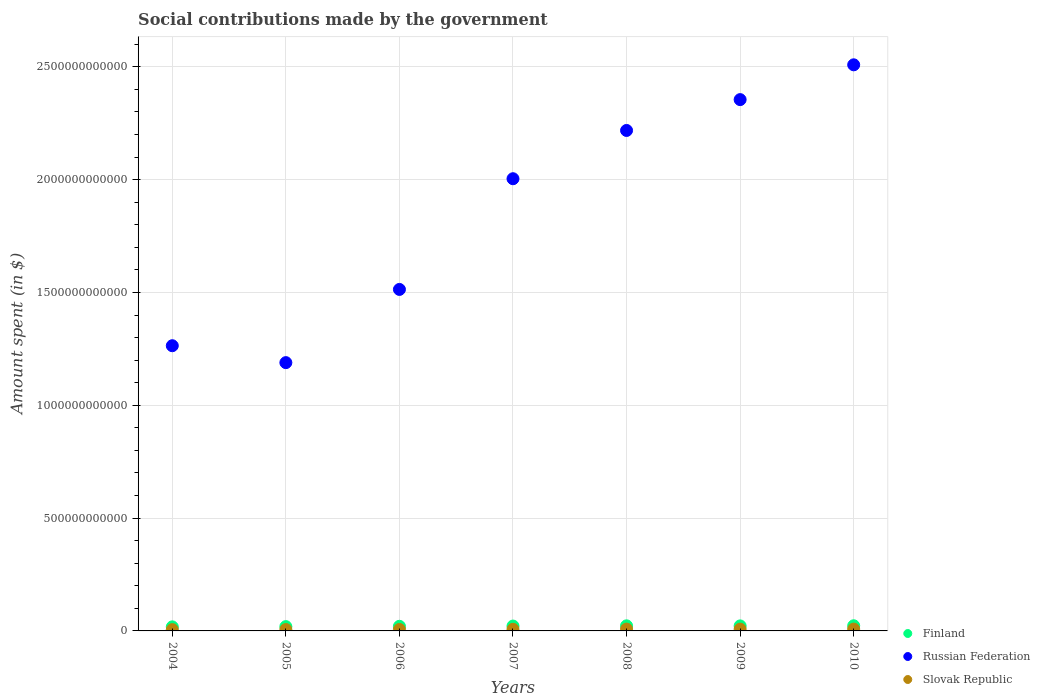What is the amount spent on social contributions in Slovak Republic in 2007?
Give a very brief answer. 7.23e+09. Across all years, what is the maximum amount spent on social contributions in Slovak Republic?
Offer a very short reply. 8.18e+09. Across all years, what is the minimum amount spent on social contributions in Slovak Republic?
Provide a short and direct response. 5.69e+09. What is the total amount spent on social contributions in Russian Federation in the graph?
Provide a short and direct response. 1.31e+13. What is the difference between the amount spent on social contributions in Finland in 2004 and that in 2009?
Keep it short and to the point. -4.28e+09. What is the difference between the amount spent on social contributions in Russian Federation in 2007 and the amount spent on social contributions in Slovak Republic in 2008?
Keep it short and to the point. 2.00e+12. What is the average amount spent on social contributions in Finland per year?
Offer a very short reply. 2.10e+1. In the year 2010, what is the difference between the amount spent on social contributions in Russian Federation and amount spent on social contributions in Finland?
Ensure brevity in your answer.  2.49e+12. What is the ratio of the amount spent on social contributions in Russian Federation in 2005 to that in 2010?
Your response must be concise. 0.47. What is the difference between the highest and the second highest amount spent on social contributions in Finland?
Your answer should be compact. 3.15e+08. What is the difference between the highest and the lowest amount spent on social contributions in Finland?
Give a very brief answer. 4.89e+09. Is it the case that in every year, the sum of the amount spent on social contributions in Russian Federation and amount spent on social contributions in Slovak Republic  is greater than the amount spent on social contributions in Finland?
Provide a short and direct response. Yes. Does the amount spent on social contributions in Finland monotonically increase over the years?
Make the answer very short. No. Is the amount spent on social contributions in Russian Federation strictly less than the amount spent on social contributions in Finland over the years?
Offer a terse response. No. How many dotlines are there?
Keep it short and to the point. 3. What is the difference between two consecutive major ticks on the Y-axis?
Make the answer very short. 5.00e+11. Where does the legend appear in the graph?
Offer a very short reply. Bottom right. How are the legend labels stacked?
Offer a very short reply. Vertical. What is the title of the graph?
Give a very brief answer. Social contributions made by the government. What is the label or title of the X-axis?
Ensure brevity in your answer.  Years. What is the label or title of the Y-axis?
Your answer should be compact. Amount spent (in $). What is the Amount spent (in $) of Finland in 2004?
Give a very brief answer. 1.80e+1. What is the Amount spent (in $) in Russian Federation in 2004?
Your answer should be very brief. 1.26e+12. What is the Amount spent (in $) in Slovak Republic in 2004?
Your response must be concise. 5.69e+09. What is the Amount spent (in $) of Finland in 2005?
Provide a succinct answer. 1.91e+1. What is the Amount spent (in $) of Russian Federation in 2005?
Your answer should be compact. 1.19e+12. What is the Amount spent (in $) of Slovak Republic in 2005?
Make the answer very short. 6.11e+09. What is the Amount spent (in $) in Finland in 2006?
Ensure brevity in your answer.  2.05e+1. What is the Amount spent (in $) of Russian Federation in 2006?
Offer a terse response. 1.51e+12. What is the Amount spent (in $) in Slovak Republic in 2006?
Provide a short and direct response. 6.59e+09. What is the Amount spent (in $) in Finland in 2007?
Ensure brevity in your answer.  2.16e+1. What is the Amount spent (in $) of Russian Federation in 2007?
Offer a very short reply. 2.00e+12. What is the Amount spent (in $) in Slovak Republic in 2007?
Keep it short and to the point. 7.23e+09. What is the Amount spent (in $) of Finland in 2008?
Give a very brief answer. 2.25e+1. What is the Amount spent (in $) in Russian Federation in 2008?
Provide a short and direct response. 2.22e+12. What is the Amount spent (in $) in Slovak Republic in 2008?
Provide a succinct answer. 8.07e+09. What is the Amount spent (in $) of Finland in 2009?
Your answer should be very brief. 2.22e+1. What is the Amount spent (in $) of Russian Federation in 2009?
Your answer should be very brief. 2.35e+12. What is the Amount spent (in $) in Slovak Republic in 2009?
Offer a terse response. 7.99e+09. What is the Amount spent (in $) of Finland in 2010?
Offer a very short reply. 2.29e+1. What is the Amount spent (in $) of Russian Federation in 2010?
Your response must be concise. 2.51e+12. What is the Amount spent (in $) of Slovak Republic in 2010?
Your response must be concise. 8.18e+09. Across all years, what is the maximum Amount spent (in $) in Finland?
Offer a terse response. 2.29e+1. Across all years, what is the maximum Amount spent (in $) of Russian Federation?
Your answer should be compact. 2.51e+12. Across all years, what is the maximum Amount spent (in $) of Slovak Republic?
Provide a short and direct response. 8.18e+09. Across all years, what is the minimum Amount spent (in $) in Finland?
Offer a terse response. 1.80e+1. Across all years, what is the minimum Amount spent (in $) in Russian Federation?
Give a very brief answer. 1.19e+12. Across all years, what is the minimum Amount spent (in $) in Slovak Republic?
Make the answer very short. 5.69e+09. What is the total Amount spent (in $) of Finland in the graph?
Your answer should be very brief. 1.47e+11. What is the total Amount spent (in $) of Russian Federation in the graph?
Your answer should be compact. 1.31e+13. What is the total Amount spent (in $) in Slovak Republic in the graph?
Offer a terse response. 4.99e+1. What is the difference between the Amount spent (in $) in Finland in 2004 and that in 2005?
Offer a terse response. -1.12e+09. What is the difference between the Amount spent (in $) in Russian Federation in 2004 and that in 2005?
Offer a very short reply. 7.49e+1. What is the difference between the Amount spent (in $) in Slovak Republic in 2004 and that in 2005?
Provide a short and direct response. -4.22e+08. What is the difference between the Amount spent (in $) in Finland in 2004 and that in 2006?
Keep it short and to the point. -2.52e+09. What is the difference between the Amount spent (in $) of Russian Federation in 2004 and that in 2006?
Offer a very short reply. -2.49e+11. What is the difference between the Amount spent (in $) of Slovak Republic in 2004 and that in 2006?
Offer a terse response. -8.98e+08. What is the difference between the Amount spent (in $) of Finland in 2004 and that in 2007?
Offer a very short reply. -3.63e+09. What is the difference between the Amount spent (in $) of Russian Federation in 2004 and that in 2007?
Provide a succinct answer. -7.40e+11. What is the difference between the Amount spent (in $) in Slovak Republic in 2004 and that in 2007?
Your response must be concise. -1.54e+09. What is the difference between the Amount spent (in $) of Finland in 2004 and that in 2008?
Give a very brief answer. -4.57e+09. What is the difference between the Amount spent (in $) of Russian Federation in 2004 and that in 2008?
Your answer should be very brief. -9.54e+11. What is the difference between the Amount spent (in $) of Slovak Republic in 2004 and that in 2008?
Provide a short and direct response. -2.38e+09. What is the difference between the Amount spent (in $) of Finland in 2004 and that in 2009?
Give a very brief answer. -4.28e+09. What is the difference between the Amount spent (in $) of Russian Federation in 2004 and that in 2009?
Provide a succinct answer. -1.09e+12. What is the difference between the Amount spent (in $) in Slovak Republic in 2004 and that in 2009?
Provide a short and direct response. -2.30e+09. What is the difference between the Amount spent (in $) in Finland in 2004 and that in 2010?
Your response must be concise. -4.89e+09. What is the difference between the Amount spent (in $) of Russian Federation in 2004 and that in 2010?
Keep it short and to the point. -1.24e+12. What is the difference between the Amount spent (in $) of Slovak Republic in 2004 and that in 2010?
Ensure brevity in your answer.  -2.49e+09. What is the difference between the Amount spent (in $) of Finland in 2005 and that in 2006?
Keep it short and to the point. -1.39e+09. What is the difference between the Amount spent (in $) of Russian Federation in 2005 and that in 2006?
Offer a very short reply. -3.24e+11. What is the difference between the Amount spent (in $) of Slovak Republic in 2005 and that in 2006?
Ensure brevity in your answer.  -4.75e+08. What is the difference between the Amount spent (in $) in Finland in 2005 and that in 2007?
Your answer should be very brief. -2.50e+09. What is the difference between the Amount spent (in $) of Russian Federation in 2005 and that in 2007?
Give a very brief answer. -8.15e+11. What is the difference between the Amount spent (in $) in Slovak Republic in 2005 and that in 2007?
Make the answer very short. -1.12e+09. What is the difference between the Amount spent (in $) of Finland in 2005 and that in 2008?
Offer a very short reply. -3.45e+09. What is the difference between the Amount spent (in $) of Russian Federation in 2005 and that in 2008?
Your answer should be compact. -1.03e+12. What is the difference between the Amount spent (in $) in Slovak Republic in 2005 and that in 2008?
Give a very brief answer. -1.96e+09. What is the difference between the Amount spent (in $) in Finland in 2005 and that in 2009?
Offer a terse response. -3.15e+09. What is the difference between the Amount spent (in $) of Russian Federation in 2005 and that in 2009?
Your response must be concise. -1.17e+12. What is the difference between the Amount spent (in $) in Slovak Republic in 2005 and that in 2009?
Provide a succinct answer. -1.88e+09. What is the difference between the Amount spent (in $) of Finland in 2005 and that in 2010?
Your answer should be compact. -3.76e+09. What is the difference between the Amount spent (in $) of Russian Federation in 2005 and that in 2010?
Keep it short and to the point. -1.32e+12. What is the difference between the Amount spent (in $) of Slovak Republic in 2005 and that in 2010?
Provide a short and direct response. -2.07e+09. What is the difference between the Amount spent (in $) of Finland in 2006 and that in 2007?
Provide a short and direct response. -1.11e+09. What is the difference between the Amount spent (in $) of Russian Federation in 2006 and that in 2007?
Give a very brief answer. -4.91e+11. What is the difference between the Amount spent (in $) of Slovak Republic in 2006 and that in 2007?
Give a very brief answer. -6.41e+08. What is the difference between the Amount spent (in $) in Finland in 2006 and that in 2008?
Your response must be concise. -2.05e+09. What is the difference between the Amount spent (in $) in Russian Federation in 2006 and that in 2008?
Offer a terse response. -7.04e+11. What is the difference between the Amount spent (in $) in Slovak Republic in 2006 and that in 2008?
Offer a very short reply. -1.48e+09. What is the difference between the Amount spent (in $) in Finland in 2006 and that in 2009?
Give a very brief answer. -1.76e+09. What is the difference between the Amount spent (in $) of Russian Federation in 2006 and that in 2009?
Provide a succinct answer. -8.41e+11. What is the difference between the Amount spent (in $) of Slovak Republic in 2006 and that in 2009?
Offer a terse response. -1.41e+09. What is the difference between the Amount spent (in $) of Finland in 2006 and that in 2010?
Offer a terse response. -2.37e+09. What is the difference between the Amount spent (in $) in Russian Federation in 2006 and that in 2010?
Your response must be concise. -9.95e+11. What is the difference between the Amount spent (in $) of Slovak Republic in 2006 and that in 2010?
Your response must be concise. -1.60e+09. What is the difference between the Amount spent (in $) of Finland in 2007 and that in 2008?
Offer a very short reply. -9.45e+08. What is the difference between the Amount spent (in $) in Russian Federation in 2007 and that in 2008?
Offer a terse response. -2.14e+11. What is the difference between the Amount spent (in $) in Slovak Republic in 2007 and that in 2008?
Give a very brief answer. -8.43e+08. What is the difference between the Amount spent (in $) in Finland in 2007 and that in 2009?
Your answer should be compact. -6.51e+08. What is the difference between the Amount spent (in $) in Russian Federation in 2007 and that in 2009?
Offer a terse response. -3.51e+11. What is the difference between the Amount spent (in $) in Slovak Republic in 2007 and that in 2009?
Provide a short and direct response. -7.65e+08. What is the difference between the Amount spent (in $) in Finland in 2007 and that in 2010?
Offer a terse response. -1.26e+09. What is the difference between the Amount spent (in $) in Russian Federation in 2007 and that in 2010?
Provide a succinct answer. -5.05e+11. What is the difference between the Amount spent (in $) in Slovak Republic in 2007 and that in 2010?
Offer a very short reply. -9.55e+08. What is the difference between the Amount spent (in $) in Finland in 2008 and that in 2009?
Keep it short and to the point. 2.94e+08. What is the difference between the Amount spent (in $) of Russian Federation in 2008 and that in 2009?
Provide a short and direct response. -1.37e+11. What is the difference between the Amount spent (in $) of Slovak Republic in 2008 and that in 2009?
Provide a short and direct response. 7.78e+07. What is the difference between the Amount spent (in $) of Finland in 2008 and that in 2010?
Your response must be concise. -3.15e+08. What is the difference between the Amount spent (in $) in Russian Federation in 2008 and that in 2010?
Give a very brief answer. -2.91e+11. What is the difference between the Amount spent (in $) of Slovak Republic in 2008 and that in 2010?
Your response must be concise. -1.13e+08. What is the difference between the Amount spent (in $) in Finland in 2009 and that in 2010?
Offer a very short reply. -6.09e+08. What is the difference between the Amount spent (in $) of Russian Federation in 2009 and that in 2010?
Offer a very short reply. -1.54e+11. What is the difference between the Amount spent (in $) in Slovak Republic in 2009 and that in 2010?
Keep it short and to the point. -1.91e+08. What is the difference between the Amount spent (in $) in Finland in 2004 and the Amount spent (in $) in Russian Federation in 2005?
Offer a terse response. -1.17e+12. What is the difference between the Amount spent (in $) of Finland in 2004 and the Amount spent (in $) of Slovak Republic in 2005?
Ensure brevity in your answer.  1.19e+1. What is the difference between the Amount spent (in $) in Russian Federation in 2004 and the Amount spent (in $) in Slovak Republic in 2005?
Make the answer very short. 1.26e+12. What is the difference between the Amount spent (in $) in Finland in 2004 and the Amount spent (in $) in Russian Federation in 2006?
Your answer should be very brief. -1.50e+12. What is the difference between the Amount spent (in $) in Finland in 2004 and the Amount spent (in $) in Slovak Republic in 2006?
Ensure brevity in your answer.  1.14e+1. What is the difference between the Amount spent (in $) in Russian Federation in 2004 and the Amount spent (in $) in Slovak Republic in 2006?
Your response must be concise. 1.26e+12. What is the difference between the Amount spent (in $) in Finland in 2004 and the Amount spent (in $) in Russian Federation in 2007?
Offer a terse response. -1.99e+12. What is the difference between the Amount spent (in $) of Finland in 2004 and the Amount spent (in $) of Slovak Republic in 2007?
Offer a very short reply. 1.07e+1. What is the difference between the Amount spent (in $) of Russian Federation in 2004 and the Amount spent (in $) of Slovak Republic in 2007?
Your response must be concise. 1.26e+12. What is the difference between the Amount spent (in $) in Finland in 2004 and the Amount spent (in $) in Russian Federation in 2008?
Provide a succinct answer. -2.20e+12. What is the difference between the Amount spent (in $) of Finland in 2004 and the Amount spent (in $) of Slovak Republic in 2008?
Your answer should be very brief. 9.90e+09. What is the difference between the Amount spent (in $) of Russian Federation in 2004 and the Amount spent (in $) of Slovak Republic in 2008?
Offer a terse response. 1.26e+12. What is the difference between the Amount spent (in $) of Finland in 2004 and the Amount spent (in $) of Russian Federation in 2009?
Make the answer very short. -2.34e+12. What is the difference between the Amount spent (in $) in Finland in 2004 and the Amount spent (in $) in Slovak Republic in 2009?
Offer a terse response. 9.98e+09. What is the difference between the Amount spent (in $) of Russian Federation in 2004 and the Amount spent (in $) of Slovak Republic in 2009?
Give a very brief answer. 1.26e+12. What is the difference between the Amount spent (in $) in Finland in 2004 and the Amount spent (in $) in Russian Federation in 2010?
Your answer should be compact. -2.49e+12. What is the difference between the Amount spent (in $) of Finland in 2004 and the Amount spent (in $) of Slovak Republic in 2010?
Make the answer very short. 9.79e+09. What is the difference between the Amount spent (in $) in Russian Federation in 2004 and the Amount spent (in $) in Slovak Republic in 2010?
Provide a succinct answer. 1.26e+12. What is the difference between the Amount spent (in $) in Finland in 2005 and the Amount spent (in $) in Russian Federation in 2006?
Your answer should be compact. -1.49e+12. What is the difference between the Amount spent (in $) in Finland in 2005 and the Amount spent (in $) in Slovak Republic in 2006?
Your response must be concise. 1.25e+1. What is the difference between the Amount spent (in $) of Russian Federation in 2005 and the Amount spent (in $) of Slovak Republic in 2006?
Offer a terse response. 1.18e+12. What is the difference between the Amount spent (in $) in Finland in 2005 and the Amount spent (in $) in Russian Federation in 2007?
Offer a terse response. -1.98e+12. What is the difference between the Amount spent (in $) of Finland in 2005 and the Amount spent (in $) of Slovak Republic in 2007?
Give a very brief answer. 1.19e+1. What is the difference between the Amount spent (in $) of Russian Federation in 2005 and the Amount spent (in $) of Slovak Republic in 2007?
Provide a succinct answer. 1.18e+12. What is the difference between the Amount spent (in $) in Finland in 2005 and the Amount spent (in $) in Russian Federation in 2008?
Offer a very short reply. -2.20e+12. What is the difference between the Amount spent (in $) in Finland in 2005 and the Amount spent (in $) in Slovak Republic in 2008?
Make the answer very short. 1.10e+1. What is the difference between the Amount spent (in $) of Russian Federation in 2005 and the Amount spent (in $) of Slovak Republic in 2008?
Offer a terse response. 1.18e+12. What is the difference between the Amount spent (in $) in Finland in 2005 and the Amount spent (in $) in Russian Federation in 2009?
Your answer should be compact. -2.34e+12. What is the difference between the Amount spent (in $) in Finland in 2005 and the Amount spent (in $) in Slovak Republic in 2009?
Your response must be concise. 1.11e+1. What is the difference between the Amount spent (in $) of Russian Federation in 2005 and the Amount spent (in $) of Slovak Republic in 2009?
Offer a terse response. 1.18e+12. What is the difference between the Amount spent (in $) of Finland in 2005 and the Amount spent (in $) of Russian Federation in 2010?
Your response must be concise. -2.49e+12. What is the difference between the Amount spent (in $) of Finland in 2005 and the Amount spent (in $) of Slovak Republic in 2010?
Your answer should be very brief. 1.09e+1. What is the difference between the Amount spent (in $) of Russian Federation in 2005 and the Amount spent (in $) of Slovak Republic in 2010?
Your answer should be compact. 1.18e+12. What is the difference between the Amount spent (in $) in Finland in 2006 and the Amount spent (in $) in Russian Federation in 2007?
Your response must be concise. -1.98e+12. What is the difference between the Amount spent (in $) of Finland in 2006 and the Amount spent (in $) of Slovak Republic in 2007?
Your response must be concise. 1.33e+1. What is the difference between the Amount spent (in $) in Russian Federation in 2006 and the Amount spent (in $) in Slovak Republic in 2007?
Provide a succinct answer. 1.51e+12. What is the difference between the Amount spent (in $) of Finland in 2006 and the Amount spent (in $) of Russian Federation in 2008?
Make the answer very short. -2.20e+12. What is the difference between the Amount spent (in $) of Finland in 2006 and the Amount spent (in $) of Slovak Republic in 2008?
Give a very brief answer. 1.24e+1. What is the difference between the Amount spent (in $) of Russian Federation in 2006 and the Amount spent (in $) of Slovak Republic in 2008?
Your answer should be compact. 1.51e+12. What is the difference between the Amount spent (in $) in Finland in 2006 and the Amount spent (in $) in Russian Federation in 2009?
Provide a short and direct response. -2.33e+12. What is the difference between the Amount spent (in $) of Finland in 2006 and the Amount spent (in $) of Slovak Republic in 2009?
Provide a succinct answer. 1.25e+1. What is the difference between the Amount spent (in $) of Russian Federation in 2006 and the Amount spent (in $) of Slovak Republic in 2009?
Keep it short and to the point. 1.51e+12. What is the difference between the Amount spent (in $) of Finland in 2006 and the Amount spent (in $) of Russian Federation in 2010?
Provide a short and direct response. -2.49e+12. What is the difference between the Amount spent (in $) in Finland in 2006 and the Amount spent (in $) in Slovak Republic in 2010?
Your answer should be very brief. 1.23e+1. What is the difference between the Amount spent (in $) of Russian Federation in 2006 and the Amount spent (in $) of Slovak Republic in 2010?
Your answer should be compact. 1.51e+12. What is the difference between the Amount spent (in $) of Finland in 2007 and the Amount spent (in $) of Russian Federation in 2008?
Offer a very short reply. -2.20e+12. What is the difference between the Amount spent (in $) in Finland in 2007 and the Amount spent (in $) in Slovak Republic in 2008?
Keep it short and to the point. 1.35e+1. What is the difference between the Amount spent (in $) in Russian Federation in 2007 and the Amount spent (in $) in Slovak Republic in 2008?
Offer a very short reply. 2.00e+12. What is the difference between the Amount spent (in $) in Finland in 2007 and the Amount spent (in $) in Russian Federation in 2009?
Give a very brief answer. -2.33e+12. What is the difference between the Amount spent (in $) of Finland in 2007 and the Amount spent (in $) of Slovak Republic in 2009?
Your answer should be compact. 1.36e+1. What is the difference between the Amount spent (in $) of Russian Federation in 2007 and the Amount spent (in $) of Slovak Republic in 2009?
Offer a very short reply. 2.00e+12. What is the difference between the Amount spent (in $) in Finland in 2007 and the Amount spent (in $) in Russian Federation in 2010?
Provide a short and direct response. -2.49e+12. What is the difference between the Amount spent (in $) in Finland in 2007 and the Amount spent (in $) in Slovak Republic in 2010?
Provide a succinct answer. 1.34e+1. What is the difference between the Amount spent (in $) of Russian Federation in 2007 and the Amount spent (in $) of Slovak Republic in 2010?
Make the answer very short. 2.00e+12. What is the difference between the Amount spent (in $) in Finland in 2008 and the Amount spent (in $) in Russian Federation in 2009?
Offer a terse response. -2.33e+12. What is the difference between the Amount spent (in $) in Finland in 2008 and the Amount spent (in $) in Slovak Republic in 2009?
Offer a very short reply. 1.45e+1. What is the difference between the Amount spent (in $) in Russian Federation in 2008 and the Amount spent (in $) in Slovak Republic in 2009?
Your answer should be very brief. 2.21e+12. What is the difference between the Amount spent (in $) of Finland in 2008 and the Amount spent (in $) of Russian Federation in 2010?
Keep it short and to the point. -2.49e+12. What is the difference between the Amount spent (in $) of Finland in 2008 and the Amount spent (in $) of Slovak Republic in 2010?
Offer a terse response. 1.44e+1. What is the difference between the Amount spent (in $) of Russian Federation in 2008 and the Amount spent (in $) of Slovak Republic in 2010?
Offer a very short reply. 2.21e+12. What is the difference between the Amount spent (in $) in Finland in 2009 and the Amount spent (in $) in Russian Federation in 2010?
Give a very brief answer. -2.49e+12. What is the difference between the Amount spent (in $) in Finland in 2009 and the Amount spent (in $) in Slovak Republic in 2010?
Offer a terse response. 1.41e+1. What is the difference between the Amount spent (in $) of Russian Federation in 2009 and the Amount spent (in $) of Slovak Republic in 2010?
Offer a very short reply. 2.35e+12. What is the average Amount spent (in $) in Finland per year?
Provide a succinct answer. 2.10e+1. What is the average Amount spent (in $) in Russian Federation per year?
Keep it short and to the point. 1.86e+12. What is the average Amount spent (in $) of Slovak Republic per year?
Your answer should be compact. 7.12e+09. In the year 2004, what is the difference between the Amount spent (in $) in Finland and Amount spent (in $) in Russian Federation?
Provide a succinct answer. -1.25e+12. In the year 2004, what is the difference between the Amount spent (in $) in Finland and Amount spent (in $) in Slovak Republic?
Your answer should be very brief. 1.23e+1. In the year 2004, what is the difference between the Amount spent (in $) of Russian Federation and Amount spent (in $) of Slovak Republic?
Provide a succinct answer. 1.26e+12. In the year 2005, what is the difference between the Amount spent (in $) of Finland and Amount spent (in $) of Russian Federation?
Make the answer very short. -1.17e+12. In the year 2005, what is the difference between the Amount spent (in $) in Finland and Amount spent (in $) in Slovak Republic?
Make the answer very short. 1.30e+1. In the year 2005, what is the difference between the Amount spent (in $) of Russian Federation and Amount spent (in $) of Slovak Republic?
Offer a terse response. 1.18e+12. In the year 2006, what is the difference between the Amount spent (in $) of Finland and Amount spent (in $) of Russian Federation?
Offer a terse response. -1.49e+12. In the year 2006, what is the difference between the Amount spent (in $) of Finland and Amount spent (in $) of Slovak Republic?
Make the answer very short. 1.39e+1. In the year 2006, what is the difference between the Amount spent (in $) in Russian Federation and Amount spent (in $) in Slovak Republic?
Your answer should be very brief. 1.51e+12. In the year 2007, what is the difference between the Amount spent (in $) of Finland and Amount spent (in $) of Russian Federation?
Your answer should be very brief. -1.98e+12. In the year 2007, what is the difference between the Amount spent (in $) in Finland and Amount spent (in $) in Slovak Republic?
Provide a short and direct response. 1.44e+1. In the year 2007, what is the difference between the Amount spent (in $) in Russian Federation and Amount spent (in $) in Slovak Republic?
Make the answer very short. 2.00e+12. In the year 2008, what is the difference between the Amount spent (in $) of Finland and Amount spent (in $) of Russian Federation?
Provide a short and direct response. -2.20e+12. In the year 2008, what is the difference between the Amount spent (in $) in Finland and Amount spent (in $) in Slovak Republic?
Your response must be concise. 1.45e+1. In the year 2008, what is the difference between the Amount spent (in $) in Russian Federation and Amount spent (in $) in Slovak Republic?
Offer a very short reply. 2.21e+12. In the year 2009, what is the difference between the Amount spent (in $) of Finland and Amount spent (in $) of Russian Federation?
Your answer should be very brief. -2.33e+12. In the year 2009, what is the difference between the Amount spent (in $) of Finland and Amount spent (in $) of Slovak Republic?
Your answer should be compact. 1.43e+1. In the year 2009, what is the difference between the Amount spent (in $) in Russian Federation and Amount spent (in $) in Slovak Republic?
Provide a succinct answer. 2.35e+12. In the year 2010, what is the difference between the Amount spent (in $) of Finland and Amount spent (in $) of Russian Federation?
Your answer should be very brief. -2.49e+12. In the year 2010, what is the difference between the Amount spent (in $) of Finland and Amount spent (in $) of Slovak Republic?
Provide a succinct answer. 1.47e+1. In the year 2010, what is the difference between the Amount spent (in $) in Russian Federation and Amount spent (in $) in Slovak Republic?
Offer a terse response. 2.50e+12. What is the ratio of the Amount spent (in $) of Finland in 2004 to that in 2005?
Ensure brevity in your answer.  0.94. What is the ratio of the Amount spent (in $) in Russian Federation in 2004 to that in 2005?
Provide a succinct answer. 1.06. What is the ratio of the Amount spent (in $) of Slovak Republic in 2004 to that in 2005?
Make the answer very short. 0.93. What is the ratio of the Amount spent (in $) of Finland in 2004 to that in 2006?
Offer a terse response. 0.88. What is the ratio of the Amount spent (in $) in Russian Federation in 2004 to that in 2006?
Your response must be concise. 0.84. What is the ratio of the Amount spent (in $) of Slovak Republic in 2004 to that in 2006?
Provide a succinct answer. 0.86. What is the ratio of the Amount spent (in $) of Finland in 2004 to that in 2007?
Provide a succinct answer. 0.83. What is the ratio of the Amount spent (in $) in Russian Federation in 2004 to that in 2007?
Ensure brevity in your answer.  0.63. What is the ratio of the Amount spent (in $) in Slovak Republic in 2004 to that in 2007?
Your answer should be compact. 0.79. What is the ratio of the Amount spent (in $) of Finland in 2004 to that in 2008?
Keep it short and to the point. 0.8. What is the ratio of the Amount spent (in $) in Russian Federation in 2004 to that in 2008?
Provide a short and direct response. 0.57. What is the ratio of the Amount spent (in $) in Slovak Republic in 2004 to that in 2008?
Offer a very short reply. 0.7. What is the ratio of the Amount spent (in $) of Finland in 2004 to that in 2009?
Offer a terse response. 0.81. What is the ratio of the Amount spent (in $) of Russian Federation in 2004 to that in 2009?
Offer a very short reply. 0.54. What is the ratio of the Amount spent (in $) of Slovak Republic in 2004 to that in 2009?
Your response must be concise. 0.71. What is the ratio of the Amount spent (in $) in Finland in 2004 to that in 2010?
Offer a terse response. 0.79. What is the ratio of the Amount spent (in $) in Russian Federation in 2004 to that in 2010?
Your response must be concise. 0.5. What is the ratio of the Amount spent (in $) in Slovak Republic in 2004 to that in 2010?
Provide a succinct answer. 0.7. What is the ratio of the Amount spent (in $) of Finland in 2005 to that in 2006?
Offer a terse response. 0.93. What is the ratio of the Amount spent (in $) in Russian Federation in 2005 to that in 2006?
Give a very brief answer. 0.79. What is the ratio of the Amount spent (in $) in Slovak Republic in 2005 to that in 2006?
Keep it short and to the point. 0.93. What is the ratio of the Amount spent (in $) in Finland in 2005 to that in 2007?
Your answer should be compact. 0.88. What is the ratio of the Amount spent (in $) in Russian Federation in 2005 to that in 2007?
Your answer should be compact. 0.59. What is the ratio of the Amount spent (in $) of Slovak Republic in 2005 to that in 2007?
Provide a succinct answer. 0.85. What is the ratio of the Amount spent (in $) in Finland in 2005 to that in 2008?
Provide a short and direct response. 0.85. What is the ratio of the Amount spent (in $) of Russian Federation in 2005 to that in 2008?
Keep it short and to the point. 0.54. What is the ratio of the Amount spent (in $) of Slovak Republic in 2005 to that in 2008?
Make the answer very short. 0.76. What is the ratio of the Amount spent (in $) in Finland in 2005 to that in 2009?
Give a very brief answer. 0.86. What is the ratio of the Amount spent (in $) in Russian Federation in 2005 to that in 2009?
Provide a short and direct response. 0.51. What is the ratio of the Amount spent (in $) in Slovak Republic in 2005 to that in 2009?
Keep it short and to the point. 0.76. What is the ratio of the Amount spent (in $) of Finland in 2005 to that in 2010?
Provide a succinct answer. 0.84. What is the ratio of the Amount spent (in $) in Russian Federation in 2005 to that in 2010?
Your answer should be very brief. 0.47. What is the ratio of the Amount spent (in $) of Slovak Republic in 2005 to that in 2010?
Your answer should be very brief. 0.75. What is the ratio of the Amount spent (in $) in Finland in 2006 to that in 2007?
Your answer should be compact. 0.95. What is the ratio of the Amount spent (in $) of Russian Federation in 2006 to that in 2007?
Ensure brevity in your answer.  0.76. What is the ratio of the Amount spent (in $) in Slovak Republic in 2006 to that in 2007?
Offer a terse response. 0.91. What is the ratio of the Amount spent (in $) of Finland in 2006 to that in 2008?
Make the answer very short. 0.91. What is the ratio of the Amount spent (in $) of Russian Federation in 2006 to that in 2008?
Your answer should be very brief. 0.68. What is the ratio of the Amount spent (in $) of Slovak Republic in 2006 to that in 2008?
Offer a very short reply. 0.82. What is the ratio of the Amount spent (in $) of Finland in 2006 to that in 2009?
Your response must be concise. 0.92. What is the ratio of the Amount spent (in $) in Russian Federation in 2006 to that in 2009?
Keep it short and to the point. 0.64. What is the ratio of the Amount spent (in $) of Slovak Republic in 2006 to that in 2009?
Offer a terse response. 0.82. What is the ratio of the Amount spent (in $) in Finland in 2006 to that in 2010?
Your answer should be very brief. 0.9. What is the ratio of the Amount spent (in $) of Russian Federation in 2006 to that in 2010?
Make the answer very short. 0.6. What is the ratio of the Amount spent (in $) of Slovak Republic in 2006 to that in 2010?
Give a very brief answer. 0.8. What is the ratio of the Amount spent (in $) of Finland in 2007 to that in 2008?
Your answer should be very brief. 0.96. What is the ratio of the Amount spent (in $) in Russian Federation in 2007 to that in 2008?
Provide a short and direct response. 0.9. What is the ratio of the Amount spent (in $) of Slovak Republic in 2007 to that in 2008?
Offer a very short reply. 0.9. What is the ratio of the Amount spent (in $) in Finland in 2007 to that in 2009?
Ensure brevity in your answer.  0.97. What is the ratio of the Amount spent (in $) in Russian Federation in 2007 to that in 2009?
Your answer should be very brief. 0.85. What is the ratio of the Amount spent (in $) of Slovak Republic in 2007 to that in 2009?
Offer a terse response. 0.9. What is the ratio of the Amount spent (in $) in Finland in 2007 to that in 2010?
Your response must be concise. 0.94. What is the ratio of the Amount spent (in $) in Russian Federation in 2007 to that in 2010?
Give a very brief answer. 0.8. What is the ratio of the Amount spent (in $) of Slovak Republic in 2007 to that in 2010?
Make the answer very short. 0.88. What is the ratio of the Amount spent (in $) in Finland in 2008 to that in 2009?
Make the answer very short. 1.01. What is the ratio of the Amount spent (in $) of Russian Federation in 2008 to that in 2009?
Give a very brief answer. 0.94. What is the ratio of the Amount spent (in $) of Slovak Republic in 2008 to that in 2009?
Offer a terse response. 1.01. What is the ratio of the Amount spent (in $) in Finland in 2008 to that in 2010?
Your answer should be very brief. 0.99. What is the ratio of the Amount spent (in $) of Russian Federation in 2008 to that in 2010?
Your answer should be compact. 0.88. What is the ratio of the Amount spent (in $) in Slovak Republic in 2008 to that in 2010?
Provide a succinct answer. 0.99. What is the ratio of the Amount spent (in $) of Finland in 2009 to that in 2010?
Your response must be concise. 0.97. What is the ratio of the Amount spent (in $) of Russian Federation in 2009 to that in 2010?
Make the answer very short. 0.94. What is the ratio of the Amount spent (in $) in Slovak Republic in 2009 to that in 2010?
Offer a very short reply. 0.98. What is the difference between the highest and the second highest Amount spent (in $) of Finland?
Ensure brevity in your answer.  3.15e+08. What is the difference between the highest and the second highest Amount spent (in $) in Russian Federation?
Offer a terse response. 1.54e+11. What is the difference between the highest and the second highest Amount spent (in $) in Slovak Republic?
Your answer should be very brief. 1.13e+08. What is the difference between the highest and the lowest Amount spent (in $) of Finland?
Make the answer very short. 4.89e+09. What is the difference between the highest and the lowest Amount spent (in $) of Russian Federation?
Provide a succinct answer. 1.32e+12. What is the difference between the highest and the lowest Amount spent (in $) in Slovak Republic?
Make the answer very short. 2.49e+09. 